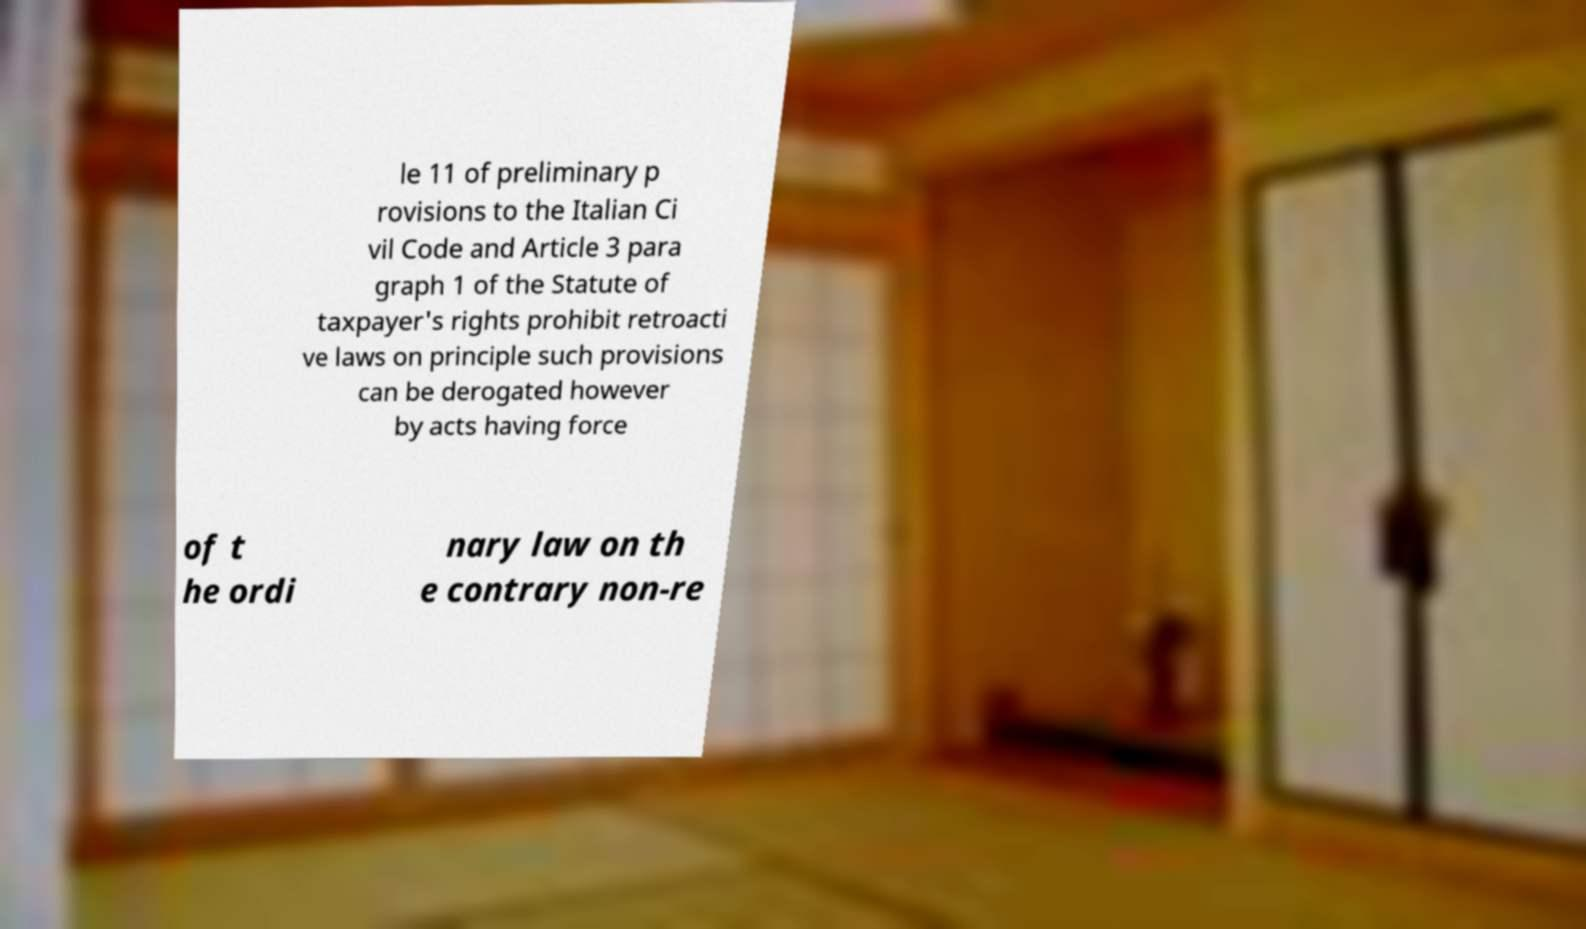Can you accurately transcribe the text from the provided image for me? le 11 of preliminary p rovisions to the Italian Ci vil Code and Article 3 para graph 1 of the Statute of taxpayer's rights prohibit retroacti ve laws on principle such provisions can be derogated however by acts having force of t he ordi nary law on th e contrary non-re 